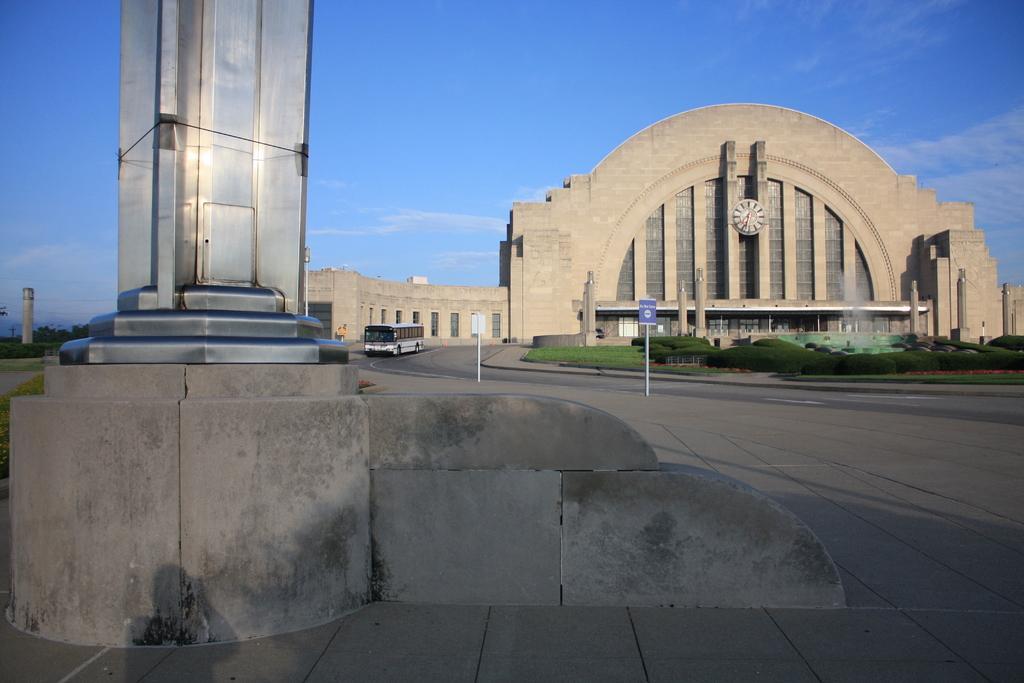Can you describe this image briefly? In this picture there is a bus On the road, beside the road we can see the grass & sign boards. In the background we can see the building. In front of the buildings we can see fountain, plants and pillars. On the building we can see the wall clock. At the top we can see sky and clouds. 